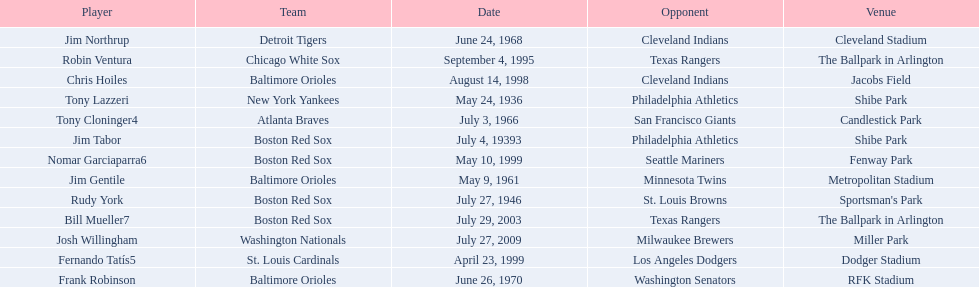Who were all the teams? New York Yankees, Boston Red Sox, Boston Red Sox, Baltimore Orioles, Atlanta Braves, Detroit Tigers, Baltimore Orioles, Chicago White Sox, Baltimore Orioles, St. Louis Cardinals, Boston Red Sox, Boston Red Sox, Washington Nationals. What about opponents? Philadelphia Athletics, Philadelphia Athletics, St. Louis Browns, Minnesota Twins, San Francisco Giants, Cleveland Indians, Washington Senators, Texas Rangers, Cleveland Indians, Los Angeles Dodgers, Seattle Mariners, Texas Rangers, Milwaukee Brewers. And when did they play? May 24, 1936, July 4, 19393, July 27, 1946, May 9, 1961, July 3, 1966, June 24, 1968, June 26, 1970, September 4, 1995, August 14, 1998, April 23, 1999, May 10, 1999, July 29, 2003, July 27, 2009. Which team played the red sox on july 27, 1946	? St. Louis Browns. 